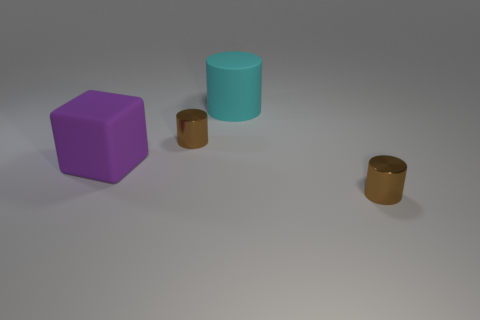Add 3 large matte objects. How many objects exist? 7 Subtract all blocks. How many objects are left? 3 Add 2 cubes. How many cubes are left? 3 Add 2 purple rubber blocks. How many purple rubber blocks exist? 3 Subtract 1 purple cubes. How many objects are left? 3 Subtract all cyan matte things. Subtract all large blue matte things. How many objects are left? 3 